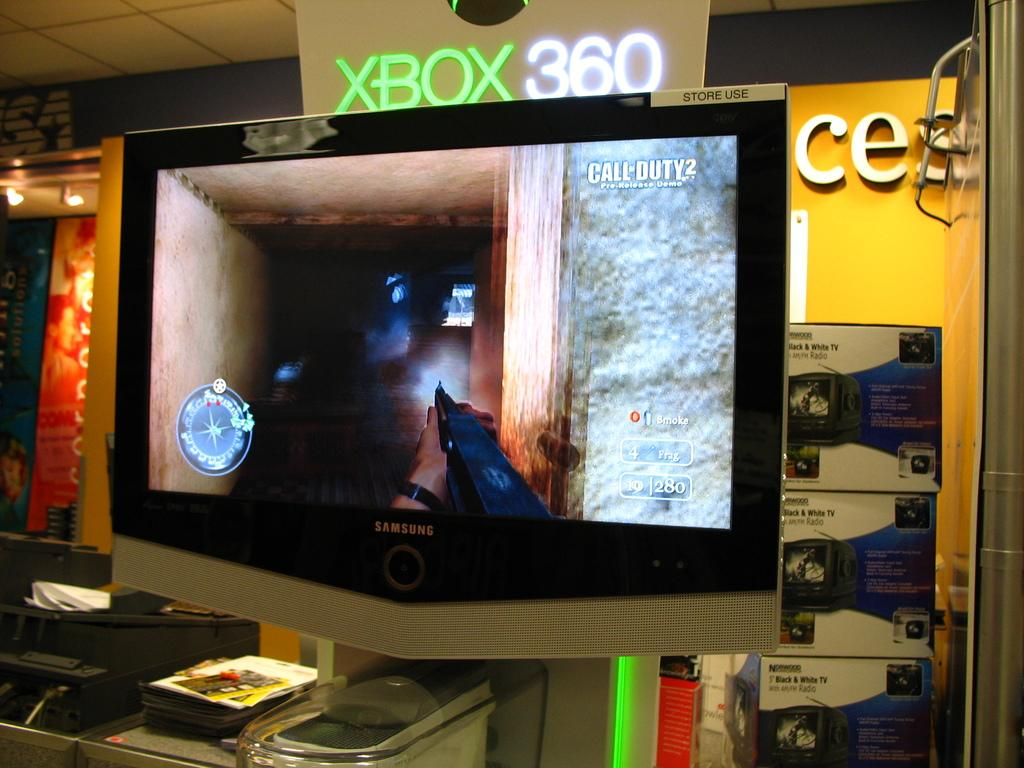<image>
Create a compact narrative representing the image presented. A screen shows moments of video game play from the XBOX 360. 